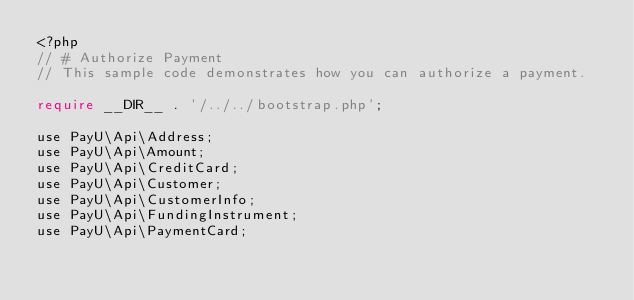Convert code to text. <code><loc_0><loc_0><loc_500><loc_500><_PHP_><?php
// # Authorize Payment
// This sample code demonstrates how you can authorize a payment.

require __DIR__ . '/../../bootstrap.php';

use PayU\Api\Address;
use PayU\Api\Amount;
use PayU\Api\CreditCard;
use PayU\Api\Customer;
use PayU\Api\CustomerInfo;
use PayU\Api\FundingInstrument;
use PayU\Api\PaymentCard;</code> 